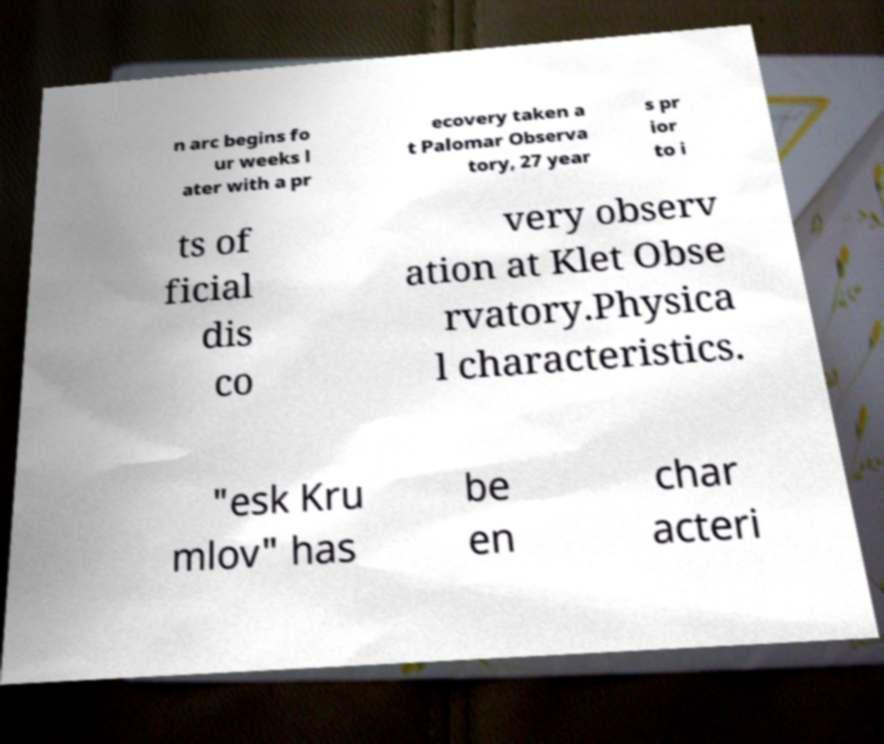Can you read and provide the text displayed in the image?This photo seems to have some interesting text. Can you extract and type it out for me? n arc begins fo ur weeks l ater with a pr ecovery taken a t Palomar Observa tory, 27 year s pr ior to i ts of ficial dis co very observ ation at Klet Obse rvatory.Physica l characteristics. "esk Kru mlov" has be en char acteri 